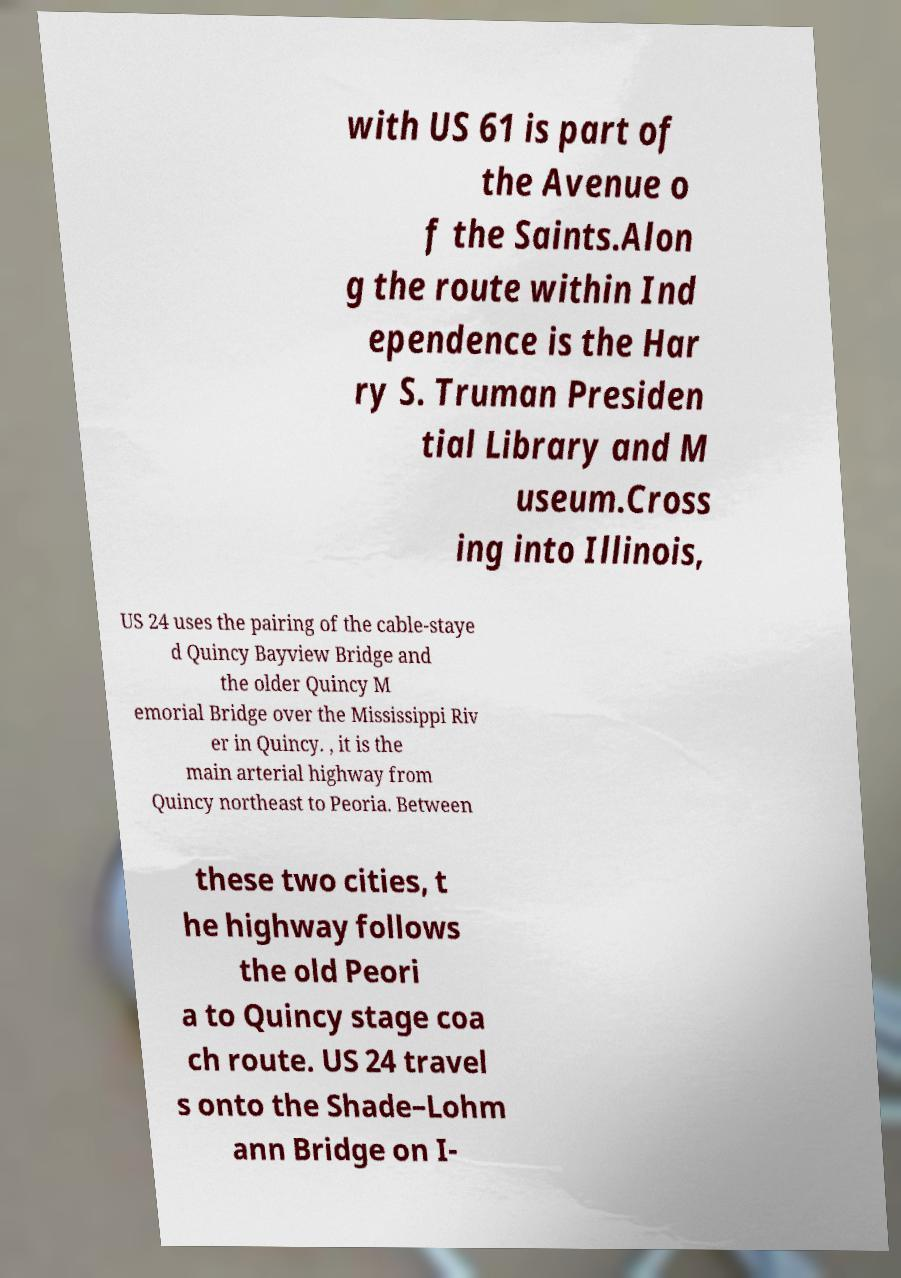Could you extract and type out the text from this image? with US 61 is part of the Avenue o f the Saints.Alon g the route within Ind ependence is the Har ry S. Truman Presiden tial Library and M useum.Cross ing into Illinois, US 24 uses the pairing of the cable-staye d Quincy Bayview Bridge and the older Quincy M emorial Bridge over the Mississippi Riv er in Quincy. , it is the main arterial highway from Quincy northeast to Peoria. Between these two cities, t he highway follows the old Peori a to Quincy stage coa ch route. US 24 travel s onto the Shade–Lohm ann Bridge on I- 